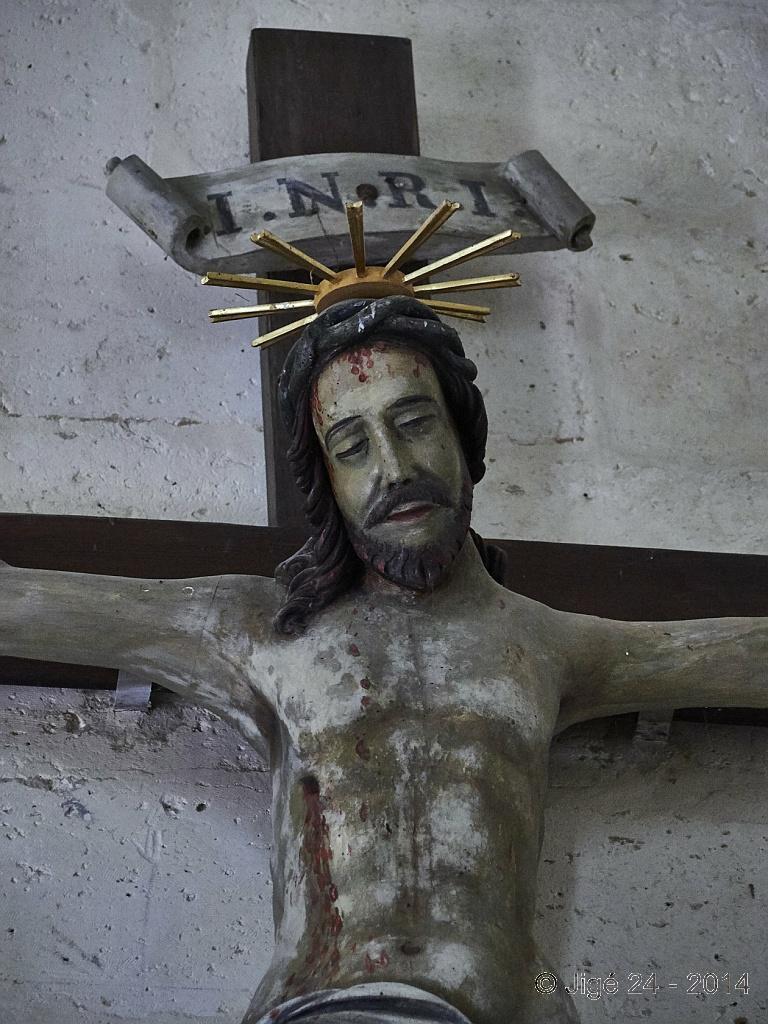In one or two sentences, can you explain what this image depicts? The picture consists of a sculpture. In the background it is well. At the bottom there is text. 